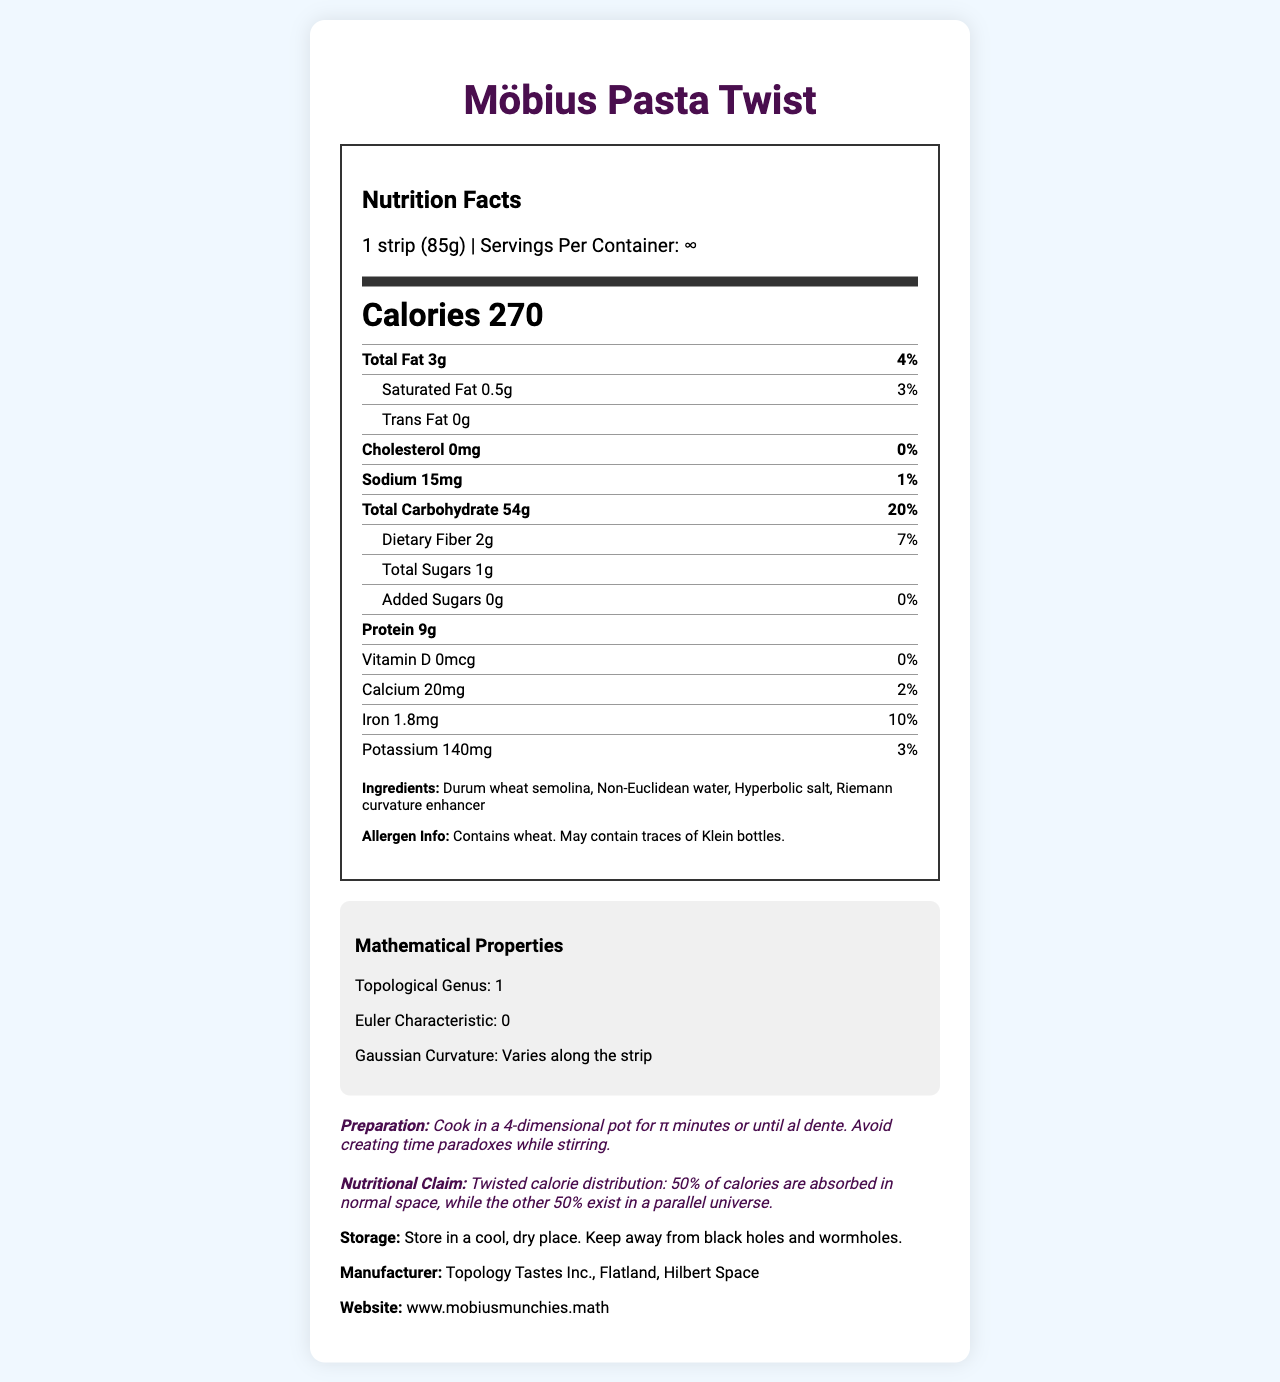what is the serving size? The serving size is mentioned at the top of the Nutrition Facts section, indicating "1 strip (85g)".
Answer: 1 strip (85g) how many calories are there per serving? The number of calories per serving is prominently displayed under the serving information as "Calories 270".
Answer: 270 what are the main ingredients in Möbius Pasta Twist? The ingredients are listed under the Ingredients section and include "Durum wheat semolina, Non-Euclidean water, Hyperbolic salt, Riemann curvature enhancer".
Answer: Durum wheat semolina, Non-Euclidean water, Hyperbolic salt, Riemann curvature enhancer what is the daily value percentage for total fat? The daily value percentage for total fat is listed next to the total fat amount, showing "4%".
Answer: 4% does Möbius Pasta Twist contain any allergens? If so, which ones? The allergen information is specified under Allergen Info, stating "Contains wheat. May contain traces of Klein bottles".
Answer: Yes, it contains wheat and may contain traces of Klein bottles what is the Euler characteristic of Möbius Pasta Twist? A. 1 B. 0 C. -1 D. 2 The Euler characteristic of the pasta is given in the Mathematical Properties section as "0".
Answer: B how should Möbius Pasta Twist be stored? A. In a refrigerator B. In a cool, dry place C. In a warm, humid place D. Under sunlight The storage instructions indicate that it should be stored in a "cool, dry place".
Answer: B does Möbius Pasta Twist require any special cooking instructions? The preparation instructions specify unique conditions: "Cook in a 4-dimensional pot for π minutes or until al dente. Avoid creating time paradoxes while stirring."
Answer: Yes does Möbius Pasta Twist contain any vitamin D? The amount of vitamin D is specified as "0mcg" with a daily value of "0%", indicating there is no vitamin D.
Answer: No what is the main idea of Möbius Pasta Twist's Nutrition Facts Label? The label provides complete nutritional information, ingredients, allergen warnings, mathematical properties, and humorous storage and preparation instructions, emphasizing its novelty and themed design.
Answer: Möbius Pasta Twist is a uniquely themed pasta with a twist on traditional nutrition, featuring non-standard mathematical properties and playful instructions. who is the manufacturer of Möbius Pasta Twist? The manufacturer's information is provided toward the end of the label, indicating "Topology Tastes Inc., Flatland, Hilbert Space".
Answer: Topology Tastes Inc., Flatland, Hilbert Space how many servings are in each container? The label humorously notes that there are "∞" servings per container, reflecting the infinite nature of a Möbius strip.
Answer: ∞ how much protein is in one serving of Möbius Pasta Twist? The protein content per serving is listed as "9g".
Answer: 9g is there a percentage daily value provided for cholesterol? (True/False) The daily value percentage for cholesterol is given as "0%", indicating it is provided.
Answer: True what is the topological genus of Möbius Pasta Twist? The Mathematical Properties section states the topological genus is "1".
Answer: The topological genus is 1. what is the source of the "twisted" calorie distribution claim? The label states the claim but does not elaborate on the underlying mechanism or source in further detail.
Answer: Not enough information 